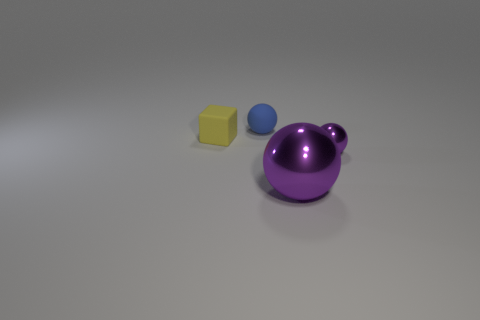What can the relative sizes of these objects tell us about their potential use or significance? The different sizes of the objects might indicate a variety of uses or significance. For instance, the small blue ball could be a simple toy or a decorative element, whereas the larger purple object, due to its size and unique shape, might be a more prominent household decorative piece or even part of a larger set of objects with a thematic or functional connection. 